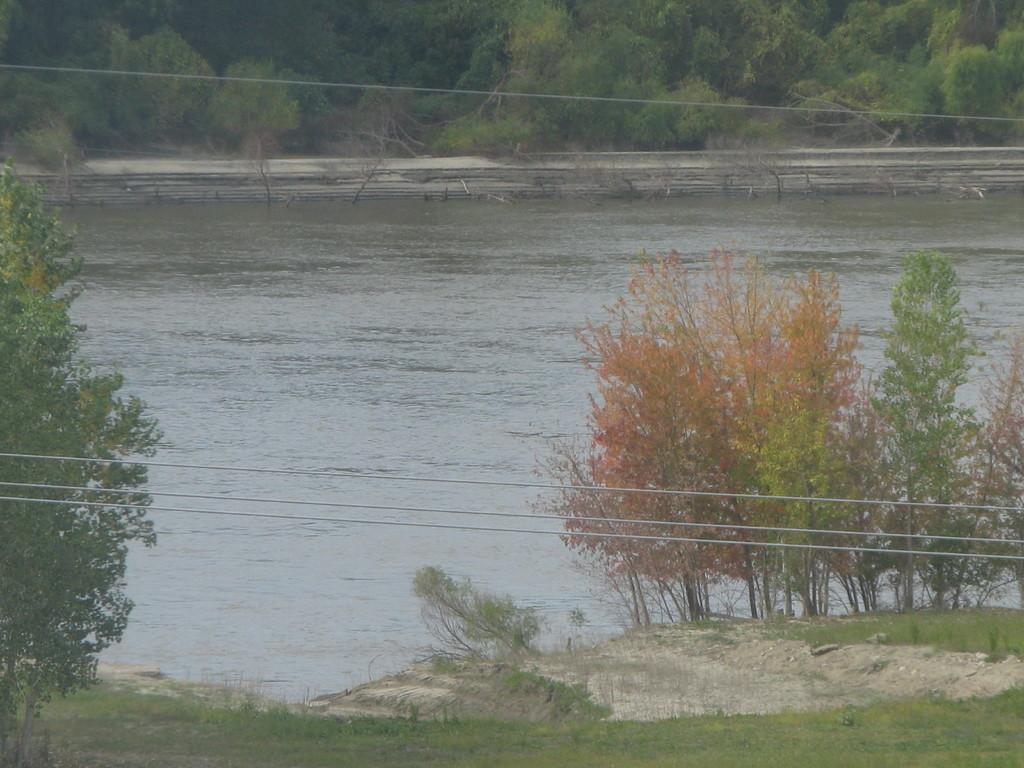What type of natural environment is visible in the image? There is grass in the image, which suggests a natural environment. What else can be seen in the image besides grass? There is water visible in the image. What man-made objects are present in the image? There are wires in the image. What can be seen in the background of the image? There are trees in the background of the image. How many windows can be seen in the image? There are no windows present in the image. What type of boot is visible in the image? There is no boot present in the image. How many clocks are visible in the image? There are no clocks present in the image. 